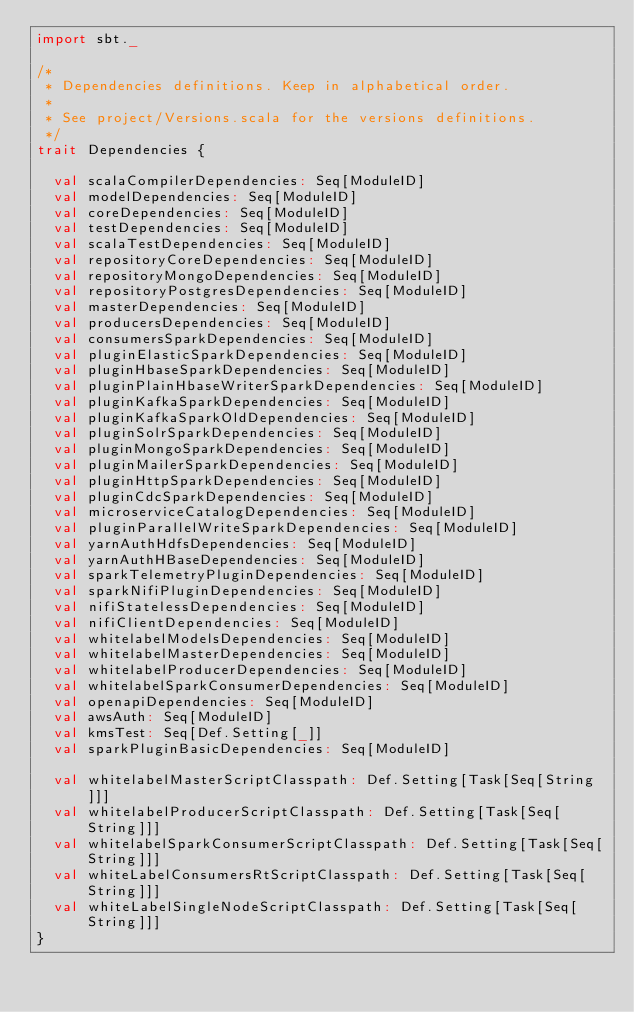Convert code to text. <code><loc_0><loc_0><loc_500><loc_500><_Scala_>import sbt._

/*
 * Dependencies definitions. Keep in alphabetical order.
 *
 * See project/Versions.scala for the versions definitions.
 */
trait Dependencies {

  val scalaCompilerDependencies: Seq[ModuleID]
  val modelDependencies: Seq[ModuleID]
  val coreDependencies: Seq[ModuleID]
  val testDependencies: Seq[ModuleID]
  val scalaTestDependencies: Seq[ModuleID]
  val repositoryCoreDependencies: Seq[ModuleID]
  val repositoryMongoDependencies: Seq[ModuleID]
  val repositoryPostgresDependencies: Seq[ModuleID]
  val masterDependencies: Seq[ModuleID]
  val producersDependencies: Seq[ModuleID]
  val consumersSparkDependencies: Seq[ModuleID]
  val pluginElasticSparkDependencies: Seq[ModuleID]
  val pluginHbaseSparkDependencies: Seq[ModuleID]
  val pluginPlainHbaseWriterSparkDependencies: Seq[ModuleID]
  val pluginKafkaSparkDependencies: Seq[ModuleID]
  val pluginKafkaSparkOldDependencies: Seq[ModuleID]
  val pluginSolrSparkDependencies: Seq[ModuleID]
  val pluginMongoSparkDependencies: Seq[ModuleID]
  val pluginMailerSparkDependencies: Seq[ModuleID]
  val pluginHttpSparkDependencies: Seq[ModuleID]
  val pluginCdcSparkDependencies: Seq[ModuleID]
  val microserviceCatalogDependencies: Seq[ModuleID]
  val pluginParallelWriteSparkDependencies: Seq[ModuleID]
  val yarnAuthHdfsDependencies: Seq[ModuleID]
  val yarnAuthHBaseDependencies: Seq[ModuleID]
  val sparkTelemetryPluginDependencies: Seq[ModuleID]
  val sparkNifiPluginDependencies: Seq[ModuleID]
  val nifiStatelessDependencies: Seq[ModuleID]
  val nifiClientDependencies: Seq[ModuleID]
  val whitelabelModelsDependencies: Seq[ModuleID]
  val whitelabelMasterDependencies: Seq[ModuleID]
  val whitelabelProducerDependencies: Seq[ModuleID]
  val whitelabelSparkConsumerDependencies: Seq[ModuleID]
  val openapiDependencies: Seq[ModuleID]
  val awsAuth: Seq[ModuleID]
  val kmsTest: Seq[Def.Setting[_]]
  val sparkPluginBasicDependencies: Seq[ModuleID]

  val whitelabelMasterScriptClasspath: Def.Setting[Task[Seq[String]]]
  val whitelabelProducerScriptClasspath: Def.Setting[Task[Seq[String]]]
  val whitelabelSparkConsumerScriptClasspath: Def.Setting[Task[Seq[String]]]
  val whiteLabelConsumersRtScriptClasspath: Def.Setting[Task[Seq[String]]]
  val whiteLabelSingleNodeScriptClasspath: Def.Setting[Task[Seq[String]]]
}
</code> 